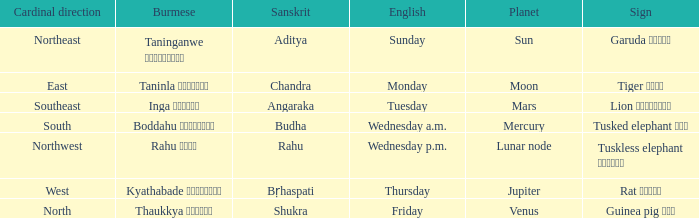What is the cardinal direction associated with Venus? North. 